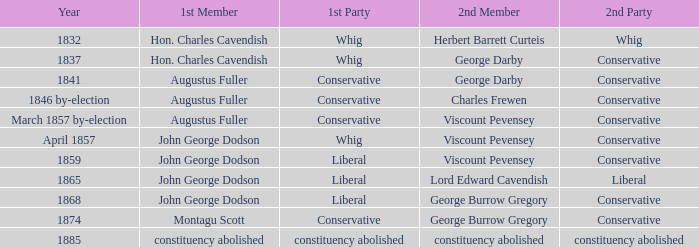In 1865, what was the first party? Liberal. 